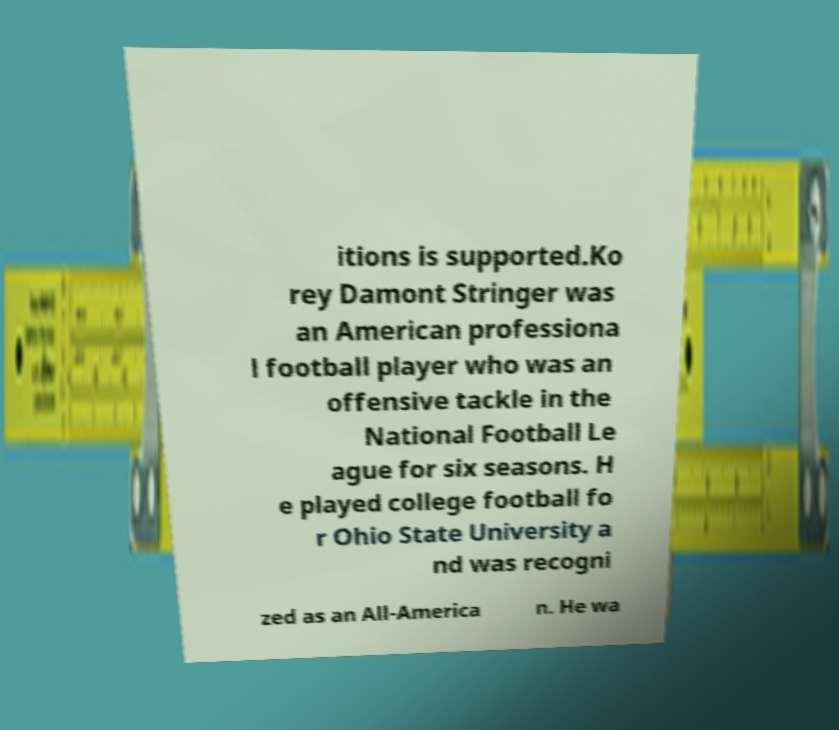Please identify and transcribe the text found in this image. itions is supported.Ko rey Damont Stringer was an American professiona l football player who was an offensive tackle in the National Football Le ague for six seasons. H e played college football fo r Ohio State University a nd was recogni zed as an All-America n. He wa 